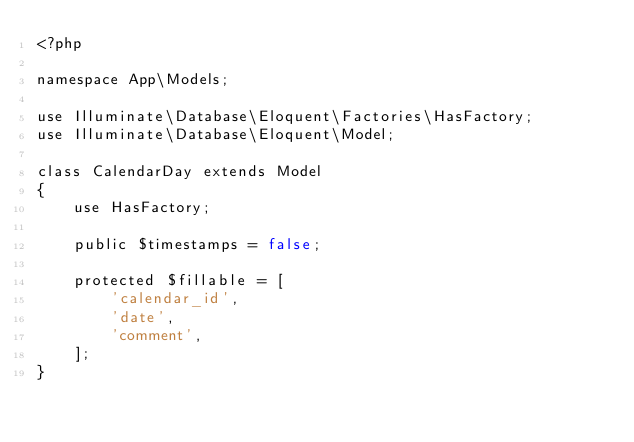<code> <loc_0><loc_0><loc_500><loc_500><_PHP_><?php

namespace App\Models;

use Illuminate\Database\Eloquent\Factories\HasFactory;
use Illuminate\Database\Eloquent\Model;

class CalendarDay extends Model
{
    use HasFactory;

    public $timestamps = false;

    protected $fillable = [
        'calendar_id',
        'date',
        'comment',
    ];
}
</code> 